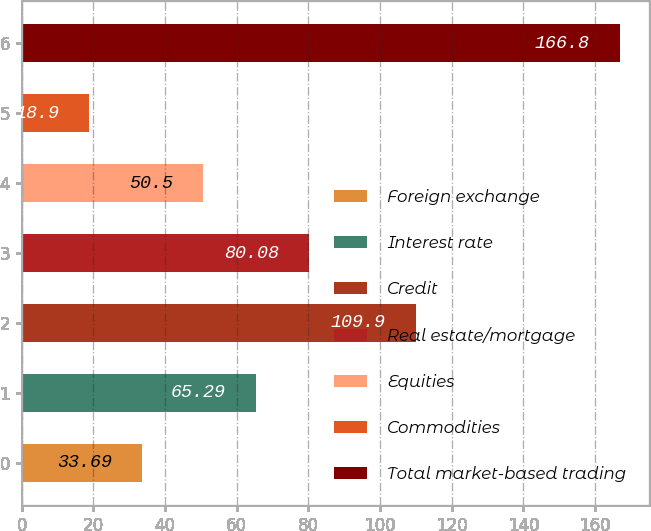Convert chart to OTSL. <chart><loc_0><loc_0><loc_500><loc_500><bar_chart><fcel>Foreign exchange<fcel>Interest rate<fcel>Credit<fcel>Real estate/mortgage<fcel>Equities<fcel>Commodities<fcel>Total market-based trading<nl><fcel>33.69<fcel>65.29<fcel>109.9<fcel>80.08<fcel>50.5<fcel>18.9<fcel>166.8<nl></chart> 